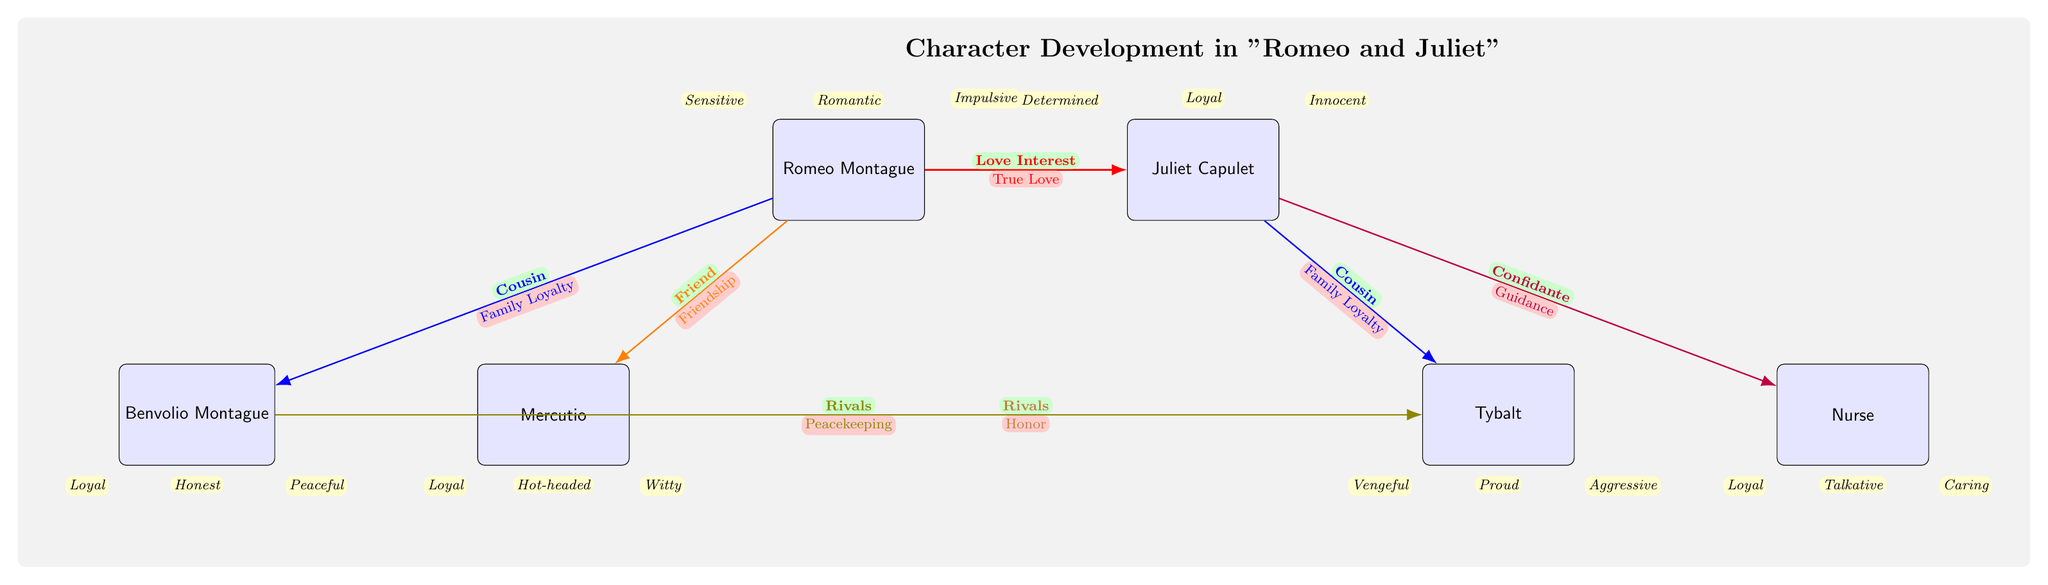What is Romeo's primary motivation for his relationship with Juliet? The diagram indicates that Romeo's motivation toward Juliet is labeled as "True Love," directly connected to the relationship line between them.
Answer: True Love How many character traits are listed for Juliet? By counting the traits listed directly above Juliet in the diagram, there are three traits shown: Innocent, Loyal, and Determined.
Answer: 3 Which character is described as "Hot-headed"? The trait "Hot-headed" is specifically listed below the character Mercutio in the diagram, indicating this is the character it describes.
Answer: Mercutio What relationship type is labeled between Mercutio and Tybalt? The diagram shows the relationship between Mercutio and Tybalt labeled as "Rivals," as indicated by the connecting arrow and the text along it.
Answer: Rivals List one trait associated with Tybalt. The diagram specifies three traits below Tybalt, one of which is "Aggressive." Any of the traits could be correct, so naming one is sufficient.
Answer: Aggressive What is the relationship between Benvolio and Tybalt? The diagram indicates that Benvolio and Tybalt have a relationship labeled as "Rivals," represented by an arrow connecting them with this description.
Answer: Rivals What trait describes the Nurse? The diagram lists three traits for the Nurse, and one of them is "Caring," which directly answers the question regarding her traits.
Answer: Caring What character is likened to being a confidante for Juliet? The relationship drawn between the Nurse and Juliet is explicitly labeled as "Confidante," indicating the Nurse's role is to provide guidance and support to Juliet.
Answer: Nurse Which character is described as being "Loyal" and is a cousin to Romeo? The character Benvolio Montague is shown connected to Romeo with the relationship labeled as "Cousin," with the shared trait of "Loyal" directly placed below Benvolio in the diagram.
Answer: Benvolio Montague 